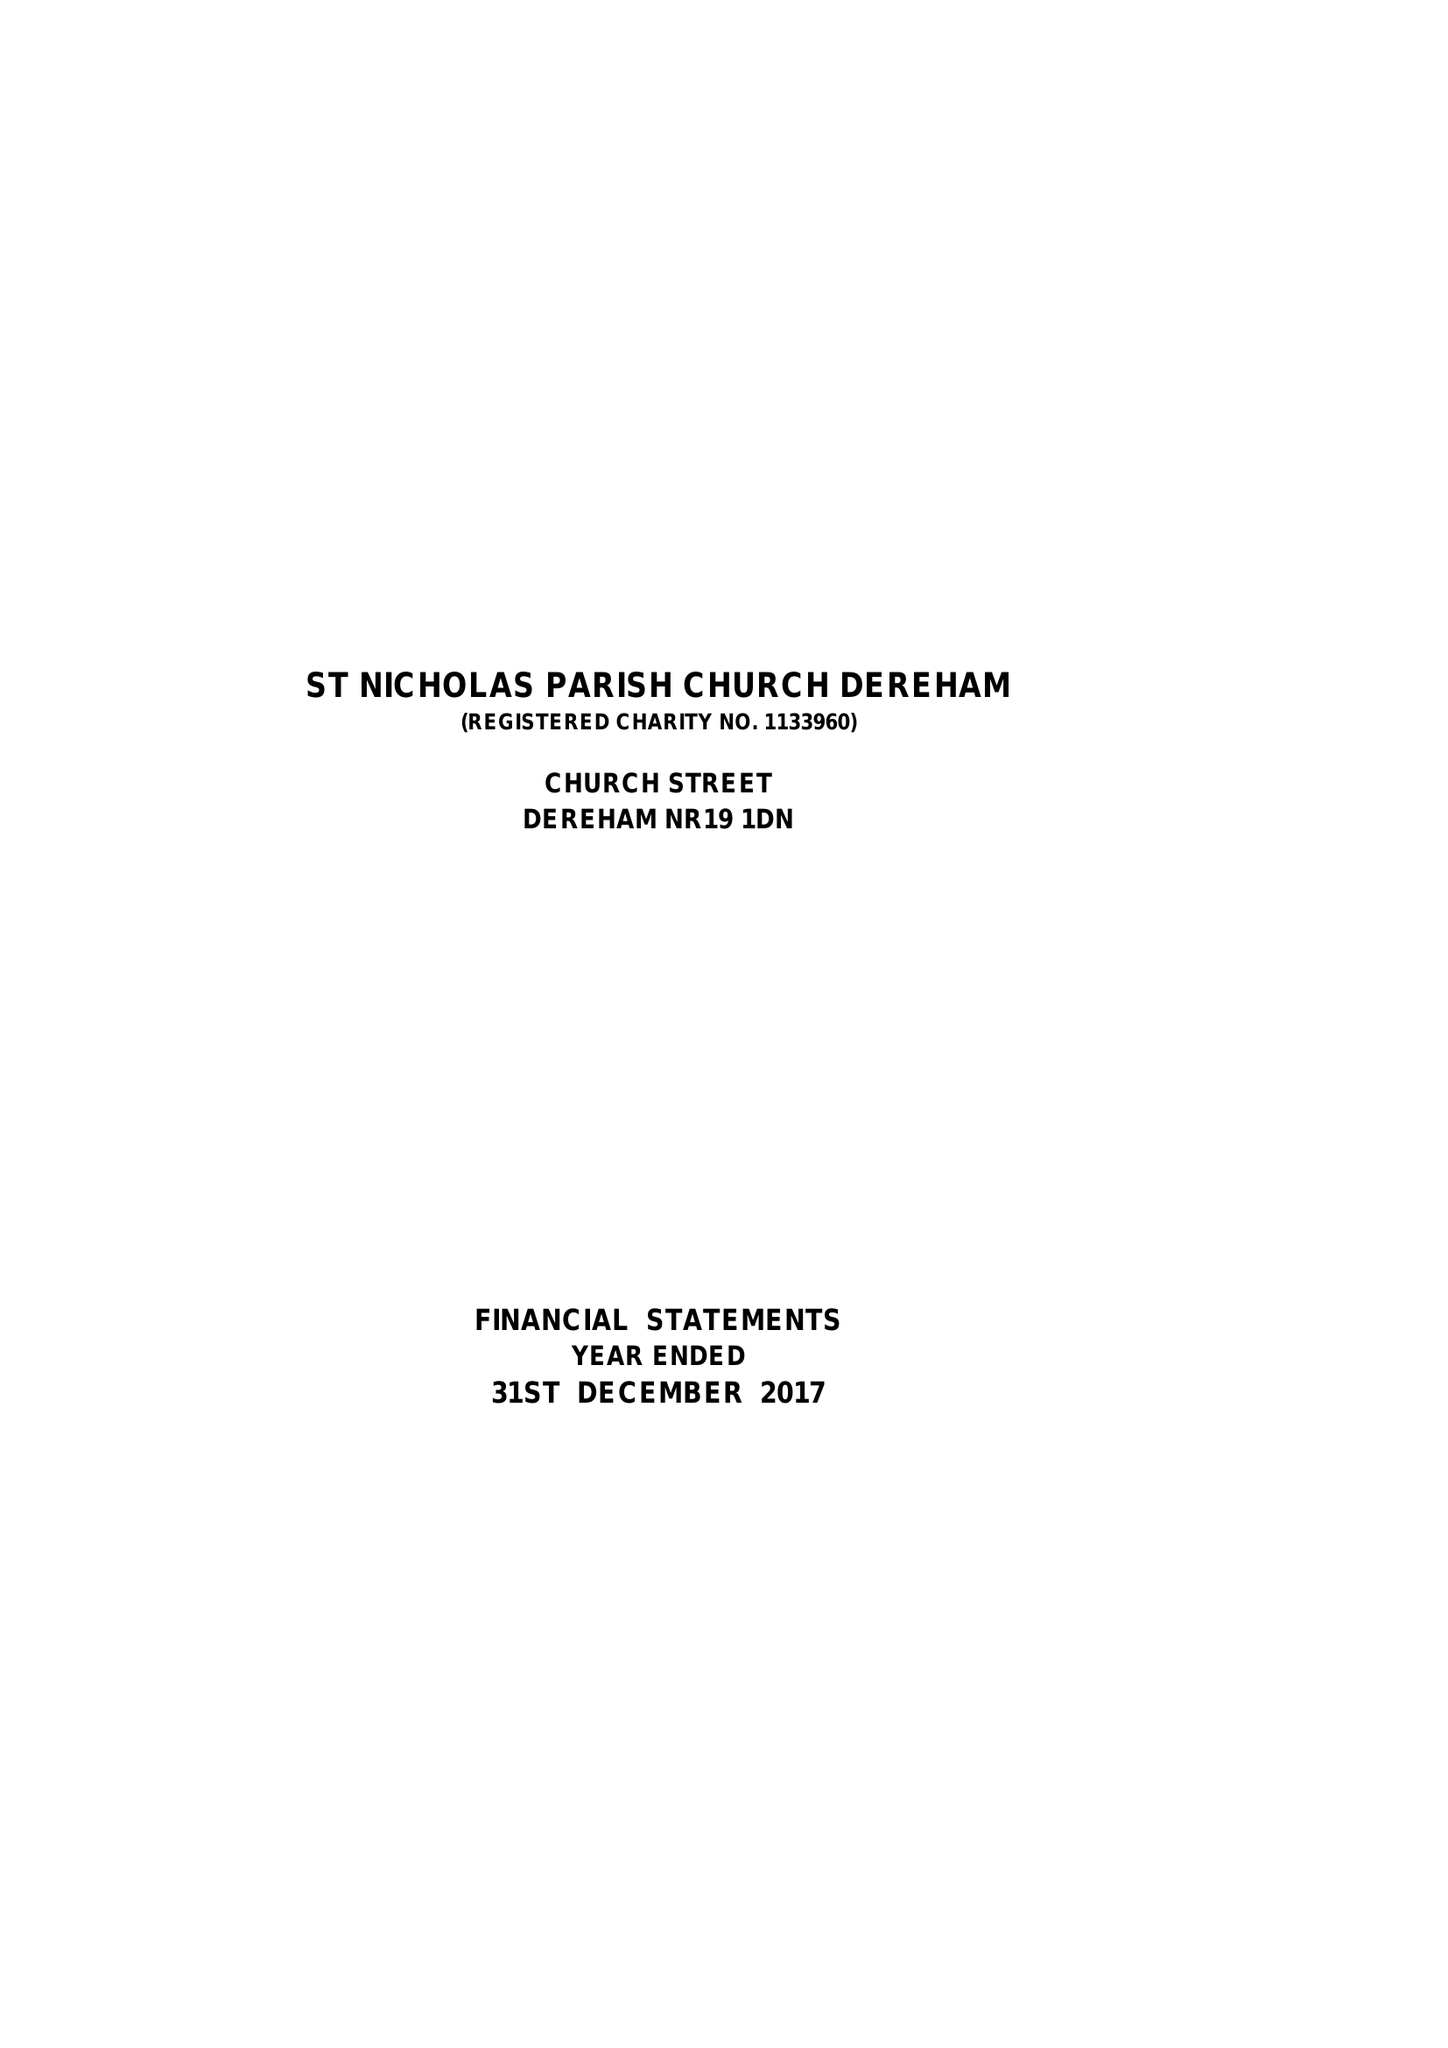What is the value for the address__postcode?
Answer the question using a single word or phrase. NR19 1DN 